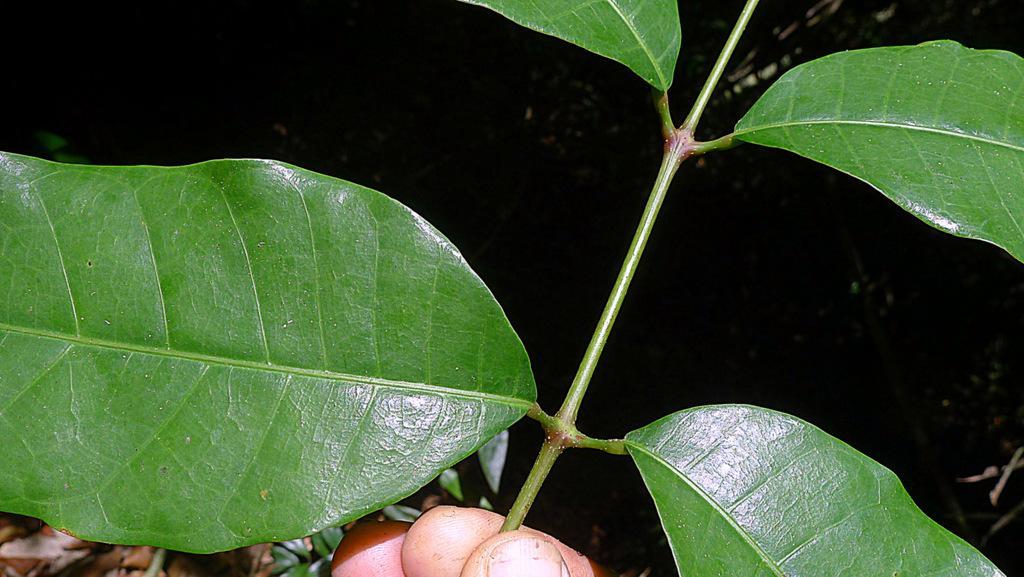Can you describe this image briefly? In the foreground of this image, there is a person´s hand holding a stem to which there are leaves and the background image is dark. 